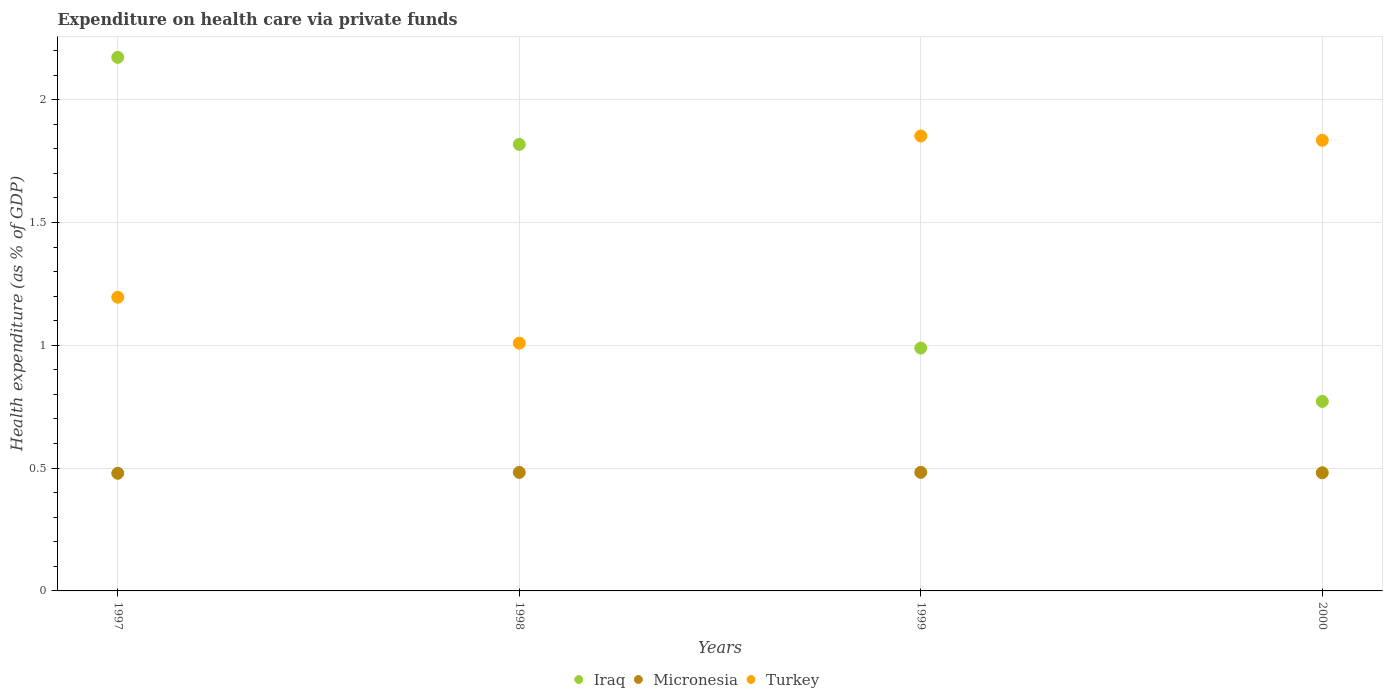Is the number of dotlines equal to the number of legend labels?
Provide a short and direct response. Yes. What is the expenditure made on health care in Turkey in 1998?
Your answer should be compact. 1.01. Across all years, what is the maximum expenditure made on health care in Micronesia?
Make the answer very short. 0.48. Across all years, what is the minimum expenditure made on health care in Micronesia?
Your response must be concise. 0.48. In which year was the expenditure made on health care in Turkey maximum?
Make the answer very short. 1999. What is the total expenditure made on health care in Turkey in the graph?
Offer a very short reply. 5.89. What is the difference between the expenditure made on health care in Iraq in 1998 and that in 2000?
Provide a short and direct response. 1.05. What is the difference between the expenditure made on health care in Micronesia in 1998 and the expenditure made on health care in Iraq in 2000?
Your answer should be compact. -0.29. What is the average expenditure made on health care in Micronesia per year?
Give a very brief answer. 0.48. In the year 1997, what is the difference between the expenditure made on health care in Iraq and expenditure made on health care in Micronesia?
Keep it short and to the point. 1.69. In how many years, is the expenditure made on health care in Turkey greater than 0.30000000000000004 %?
Your answer should be compact. 4. What is the ratio of the expenditure made on health care in Turkey in 1997 to that in 1998?
Provide a succinct answer. 1.19. What is the difference between the highest and the second highest expenditure made on health care in Turkey?
Offer a very short reply. 0.02. What is the difference between the highest and the lowest expenditure made on health care in Micronesia?
Make the answer very short. 0. Is the sum of the expenditure made on health care in Turkey in 1998 and 2000 greater than the maximum expenditure made on health care in Iraq across all years?
Give a very brief answer. Yes. Is it the case that in every year, the sum of the expenditure made on health care in Micronesia and expenditure made on health care in Iraq  is greater than the expenditure made on health care in Turkey?
Your answer should be compact. No. How many dotlines are there?
Your answer should be very brief. 3. How many years are there in the graph?
Give a very brief answer. 4. What is the difference between two consecutive major ticks on the Y-axis?
Your response must be concise. 0.5. Does the graph contain grids?
Ensure brevity in your answer.  Yes. Where does the legend appear in the graph?
Provide a succinct answer. Bottom center. How are the legend labels stacked?
Give a very brief answer. Horizontal. What is the title of the graph?
Your response must be concise. Expenditure on health care via private funds. What is the label or title of the X-axis?
Your response must be concise. Years. What is the label or title of the Y-axis?
Offer a very short reply. Health expenditure (as % of GDP). What is the Health expenditure (as % of GDP) in Iraq in 1997?
Offer a very short reply. 2.17. What is the Health expenditure (as % of GDP) of Micronesia in 1997?
Ensure brevity in your answer.  0.48. What is the Health expenditure (as % of GDP) of Turkey in 1997?
Provide a succinct answer. 1.2. What is the Health expenditure (as % of GDP) of Iraq in 1998?
Your answer should be very brief. 1.82. What is the Health expenditure (as % of GDP) in Micronesia in 1998?
Provide a succinct answer. 0.48. What is the Health expenditure (as % of GDP) of Turkey in 1998?
Your answer should be very brief. 1.01. What is the Health expenditure (as % of GDP) in Iraq in 1999?
Your answer should be compact. 0.99. What is the Health expenditure (as % of GDP) in Micronesia in 1999?
Give a very brief answer. 0.48. What is the Health expenditure (as % of GDP) in Turkey in 1999?
Provide a short and direct response. 1.85. What is the Health expenditure (as % of GDP) in Iraq in 2000?
Provide a short and direct response. 0.77. What is the Health expenditure (as % of GDP) in Micronesia in 2000?
Offer a terse response. 0.48. What is the Health expenditure (as % of GDP) of Turkey in 2000?
Your answer should be very brief. 1.83. Across all years, what is the maximum Health expenditure (as % of GDP) of Iraq?
Offer a very short reply. 2.17. Across all years, what is the maximum Health expenditure (as % of GDP) in Micronesia?
Your answer should be very brief. 0.48. Across all years, what is the maximum Health expenditure (as % of GDP) in Turkey?
Give a very brief answer. 1.85. Across all years, what is the minimum Health expenditure (as % of GDP) in Iraq?
Your response must be concise. 0.77. Across all years, what is the minimum Health expenditure (as % of GDP) in Micronesia?
Offer a terse response. 0.48. Across all years, what is the minimum Health expenditure (as % of GDP) of Turkey?
Your response must be concise. 1.01. What is the total Health expenditure (as % of GDP) in Iraq in the graph?
Provide a succinct answer. 5.75. What is the total Health expenditure (as % of GDP) of Micronesia in the graph?
Your answer should be very brief. 1.93. What is the total Health expenditure (as % of GDP) of Turkey in the graph?
Your answer should be compact. 5.89. What is the difference between the Health expenditure (as % of GDP) of Iraq in 1997 and that in 1998?
Provide a short and direct response. 0.35. What is the difference between the Health expenditure (as % of GDP) of Micronesia in 1997 and that in 1998?
Keep it short and to the point. -0. What is the difference between the Health expenditure (as % of GDP) of Turkey in 1997 and that in 1998?
Your answer should be compact. 0.19. What is the difference between the Health expenditure (as % of GDP) in Iraq in 1997 and that in 1999?
Your answer should be compact. 1.18. What is the difference between the Health expenditure (as % of GDP) of Micronesia in 1997 and that in 1999?
Make the answer very short. -0. What is the difference between the Health expenditure (as % of GDP) in Turkey in 1997 and that in 1999?
Your answer should be compact. -0.66. What is the difference between the Health expenditure (as % of GDP) of Iraq in 1997 and that in 2000?
Give a very brief answer. 1.4. What is the difference between the Health expenditure (as % of GDP) of Micronesia in 1997 and that in 2000?
Give a very brief answer. -0. What is the difference between the Health expenditure (as % of GDP) in Turkey in 1997 and that in 2000?
Give a very brief answer. -0.64. What is the difference between the Health expenditure (as % of GDP) of Iraq in 1998 and that in 1999?
Make the answer very short. 0.83. What is the difference between the Health expenditure (as % of GDP) in Micronesia in 1998 and that in 1999?
Offer a very short reply. -0. What is the difference between the Health expenditure (as % of GDP) in Turkey in 1998 and that in 1999?
Ensure brevity in your answer.  -0.84. What is the difference between the Health expenditure (as % of GDP) of Iraq in 1998 and that in 2000?
Ensure brevity in your answer.  1.05. What is the difference between the Health expenditure (as % of GDP) of Micronesia in 1998 and that in 2000?
Give a very brief answer. 0. What is the difference between the Health expenditure (as % of GDP) in Turkey in 1998 and that in 2000?
Ensure brevity in your answer.  -0.83. What is the difference between the Health expenditure (as % of GDP) in Iraq in 1999 and that in 2000?
Keep it short and to the point. 0.22. What is the difference between the Health expenditure (as % of GDP) in Micronesia in 1999 and that in 2000?
Your answer should be compact. 0. What is the difference between the Health expenditure (as % of GDP) in Turkey in 1999 and that in 2000?
Your response must be concise. 0.02. What is the difference between the Health expenditure (as % of GDP) in Iraq in 1997 and the Health expenditure (as % of GDP) in Micronesia in 1998?
Provide a short and direct response. 1.69. What is the difference between the Health expenditure (as % of GDP) in Iraq in 1997 and the Health expenditure (as % of GDP) in Turkey in 1998?
Ensure brevity in your answer.  1.16. What is the difference between the Health expenditure (as % of GDP) of Micronesia in 1997 and the Health expenditure (as % of GDP) of Turkey in 1998?
Your answer should be very brief. -0.53. What is the difference between the Health expenditure (as % of GDP) in Iraq in 1997 and the Health expenditure (as % of GDP) in Micronesia in 1999?
Make the answer very short. 1.69. What is the difference between the Health expenditure (as % of GDP) in Iraq in 1997 and the Health expenditure (as % of GDP) in Turkey in 1999?
Offer a very short reply. 0.32. What is the difference between the Health expenditure (as % of GDP) in Micronesia in 1997 and the Health expenditure (as % of GDP) in Turkey in 1999?
Give a very brief answer. -1.37. What is the difference between the Health expenditure (as % of GDP) in Iraq in 1997 and the Health expenditure (as % of GDP) in Micronesia in 2000?
Your answer should be compact. 1.69. What is the difference between the Health expenditure (as % of GDP) of Iraq in 1997 and the Health expenditure (as % of GDP) of Turkey in 2000?
Your answer should be compact. 0.34. What is the difference between the Health expenditure (as % of GDP) of Micronesia in 1997 and the Health expenditure (as % of GDP) of Turkey in 2000?
Keep it short and to the point. -1.36. What is the difference between the Health expenditure (as % of GDP) of Iraq in 1998 and the Health expenditure (as % of GDP) of Micronesia in 1999?
Make the answer very short. 1.34. What is the difference between the Health expenditure (as % of GDP) in Iraq in 1998 and the Health expenditure (as % of GDP) in Turkey in 1999?
Your response must be concise. -0.03. What is the difference between the Health expenditure (as % of GDP) in Micronesia in 1998 and the Health expenditure (as % of GDP) in Turkey in 1999?
Make the answer very short. -1.37. What is the difference between the Health expenditure (as % of GDP) in Iraq in 1998 and the Health expenditure (as % of GDP) in Micronesia in 2000?
Your answer should be compact. 1.34. What is the difference between the Health expenditure (as % of GDP) in Iraq in 1998 and the Health expenditure (as % of GDP) in Turkey in 2000?
Keep it short and to the point. -0.02. What is the difference between the Health expenditure (as % of GDP) in Micronesia in 1998 and the Health expenditure (as % of GDP) in Turkey in 2000?
Provide a short and direct response. -1.35. What is the difference between the Health expenditure (as % of GDP) in Iraq in 1999 and the Health expenditure (as % of GDP) in Micronesia in 2000?
Your answer should be very brief. 0.51. What is the difference between the Health expenditure (as % of GDP) in Iraq in 1999 and the Health expenditure (as % of GDP) in Turkey in 2000?
Keep it short and to the point. -0.85. What is the difference between the Health expenditure (as % of GDP) in Micronesia in 1999 and the Health expenditure (as % of GDP) in Turkey in 2000?
Offer a very short reply. -1.35. What is the average Health expenditure (as % of GDP) of Iraq per year?
Make the answer very short. 1.44. What is the average Health expenditure (as % of GDP) in Micronesia per year?
Your answer should be very brief. 0.48. What is the average Health expenditure (as % of GDP) of Turkey per year?
Your answer should be very brief. 1.47. In the year 1997, what is the difference between the Health expenditure (as % of GDP) of Iraq and Health expenditure (as % of GDP) of Micronesia?
Give a very brief answer. 1.69. In the year 1997, what is the difference between the Health expenditure (as % of GDP) of Iraq and Health expenditure (as % of GDP) of Turkey?
Your answer should be very brief. 0.98. In the year 1997, what is the difference between the Health expenditure (as % of GDP) of Micronesia and Health expenditure (as % of GDP) of Turkey?
Keep it short and to the point. -0.72. In the year 1998, what is the difference between the Health expenditure (as % of GDP) of Iraq and Health expenditure (as % of GDP) of Micronesia?
Your response must be concise. 1.34. In the year 1998, what is the difference between the Health expenditure (as % of GDP) of Iraq and Health expenditure (as % of GDP) of Turkey?
Make the answer very short. 0.81. In the year 1998, what is the difference between the Health expenditure (as % of GDP) of Micronesia and Health expenditure (as % of GDP) of Turkey?
Offer a very short reply. -0.53. In the year 1999, what is the difference between the Health expenditure (as % of GDP) in Iraq and Health expenditure (as % of GDP) in Micronesia?
Make the answer very short. 0.51. In the year 1999, what is the difference between the Health expenditure (as % of GDP) in Iraq and Health expenditure (as % of GDP) in Turkey?
Keep it short and to the point. -0.86. In the year 1999, what is the difference between the Health expenditure (as % of GDP) in Micronesia and Health expenditure (as % of GDP) in Turkey?
Offer a terse response. -1.37. In the year 2000, what is the difference between the Health expenditure (as % of GDP) in Iraq and Health expenditure (as % of GDP) in Micronesia?
Provide a succinct answer. 0.29. In the year 2000, what is the difference between the Health expenditure (as % of GDP) of Iraq and Health expenditure (as % of GDP) of Turkey?
Your answer should be compact. -1.06. In the year 2000, what is the difference between the Health expenditure (as % of GDP) of Micronesia and Health expenditure (as % of GDP) of Turkey?
Ensure brevity in your answer.  -1.35. What is the ratio of the Health expenditure (as % of GDP) in Iraq in 1997 to that in 1998?
Keep it short and to the point. 1.19. What is the ratio of the Health expenditure (as % of GDP) in Micronesia in 1997 to that in 1998?
Provide a short and direct response. 0.99. What is the ratio of the Health expenditure (as % of GDP) of Turkey in 1997 to that in 1998?
Offer a very short reply. 1.19. What is the ratio of the Health expenditure (as % of GDP) of Iraq in 1997 to that in 1999?
Make the answer very short. 2.2. What is the ratio of the Health expenditure (as % of GDP) in Turkey in 1997 to that in 1999?
Provide a short and direct response. 0.65. What is the ratio of the Health expenditure (as % of GDP) in Iraq in 1997 to that in 2000?
Ensure brevity in your answer.  2.82. What is the ratio of the Health expenditure (as % of GDP) in Turkey in 1997 to that in 2000?
Give a very brief answer. 0.65. What is the ratio of the Health expenditure (as % of GDP) of Iraq in 1998 to that in 1999?
Your answer should be compact. 1.84. What is the ratio of the Health expenditure (as % of GDP) in Micronesia in 1998 to that in 1999?
Keep it short and to the point. 1. What is the ratio of the Health expenditure (as % of GDP) in Turkey in 1998 to that in 1999?
Your answer should be compact. 0.54. What is the ratio of the Health expenditure (as % of GDP) of Iraq in 1998 to that in 2000?
Your answer should be compact. 2.36. What is the ratio of the Health expenditure (as % of GDP) in Micronesia in 1998 to that in 2000?
Offer a very short reply. 1. What is the ratio of the Health expenditure (as % of GDP) of Turkey in 1998 to that in 2000?
Your answer should be very brief. 0.55. What is the ratio of the Health expenditure (as % of GDP) in Iraq in 1999 to that in 2000?
Make the answer very short. 1.28. What is the ratio of the Health expenditure (as % of GDP) in Turkey in 1999 to that in 2000?
Offer a very short reply. 1.01. What is the difference between the highest and the second highest Health expenditure (as % of GDP) in Iraq?
Your response must be concise. 0.35. What is the difference between the highest and the second highest Health expenditure (as % of GDP) in Micronesia?
Offer a terse response. 0. What is the difference between the highest and the second highest Health expenditure (as % of GDP) of Turkey?
Provide a succinct answer. 0.02. What is the difference between the highest and the lowest Health expenditure (as % of GDP) in Iraq?
Give a very brief answer. 1.4. What is the difference between the highest and the lowest Health expenditure (as % of GDP) in Micronesia?
Make the answer very short. 0. What is the difference between the highest and the lowest Health expenditure (as % of GDP) of Turkey?
Offer a very short reply. 0.84. 